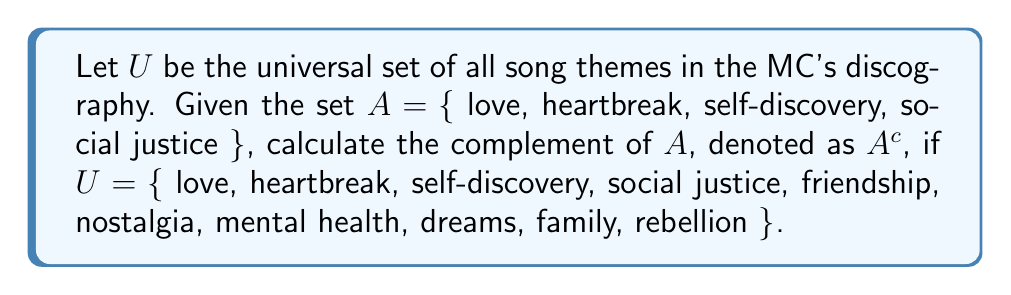Can you solve this math problem? To find the complement of set $A$, we need to identify all elements in the universal set $U$ that are not in set $A$. 

Let's follow these steps:

1. Identify the elements in set $A$:
   $A = \{$ love, heartbreak, self-discovery, social justice $\}$

2. Identify all elements in the universal set $U$:
   $U = \{$ love, heartbreak, self-discovery, social justice, friendship, nostalgia, mental health, dreams, family, rebellion $\}$

3. Find elements in $U$ that are not in $A$:
   The elements in $U$ but not in $A$ are:
   $\{$ friendship, nostalgia, mental health, dreams, family, rebellion $\}$

4. The complement of $A$, denoted as $A^c$, is the set of all elements in $U$ that are not in $A$:
   $A^c = \{$ friendship, nostalgia, mental health, dreams, family, rebellion $\}$

Therefore, the complement of set $A$ contains all the song themes in the MC's discography that are not about love, heartbreak, self-discovery, or social justice.
Answer: $A^c = \{$ friendship, nostalgia, mental health, dreams, family, rebellion $\}$ 